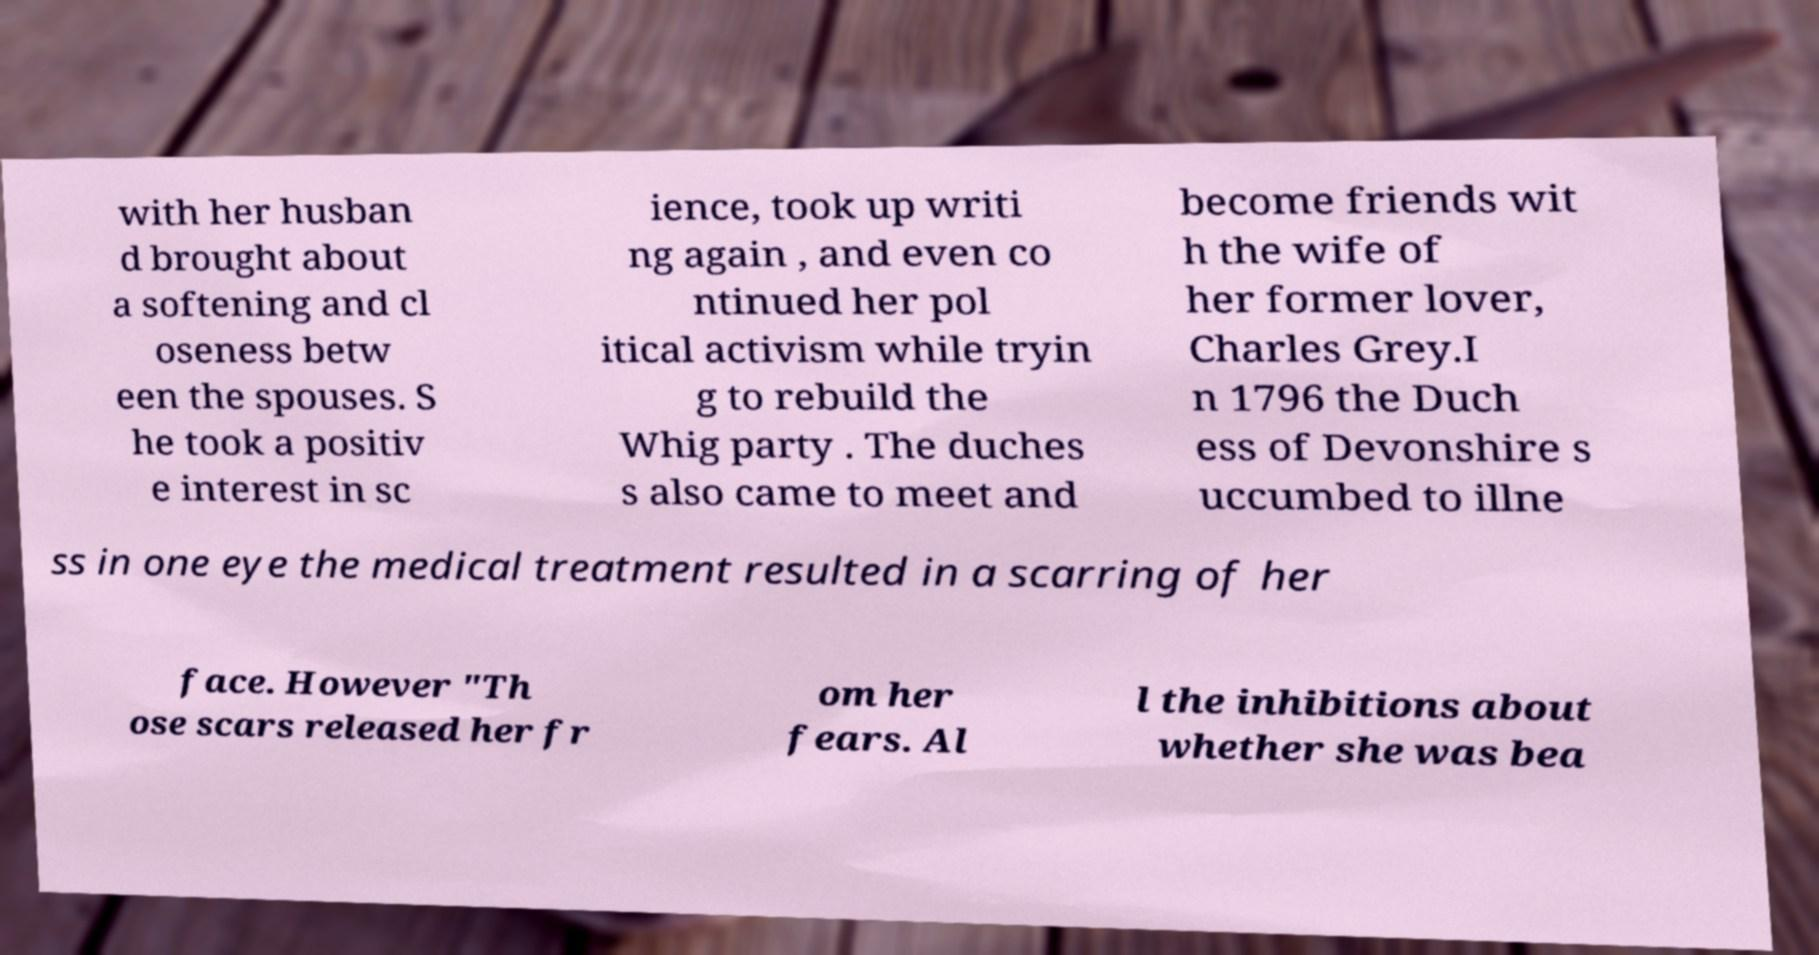Could you assist in decoding the text presented in this image and type it out clearly? with her husban d brought about a softening and cl oseness betw een the spouses. S he took a positiv e interest in sc ience, took up writi ng again , and even co ntinued her pol itical activism while tryin g to rebuild the Whig party . The duches s also came to meet and become friends wit h the wife of her former lover, Charles Grey.I n 1796 the Duch ess of Devonshire s uccumbed to illne ss in one eye the medical treatment resulted in a scarring of her face. However "Th ose scars released her fr om her fears. Al l the inhibitions about whether she was bea 